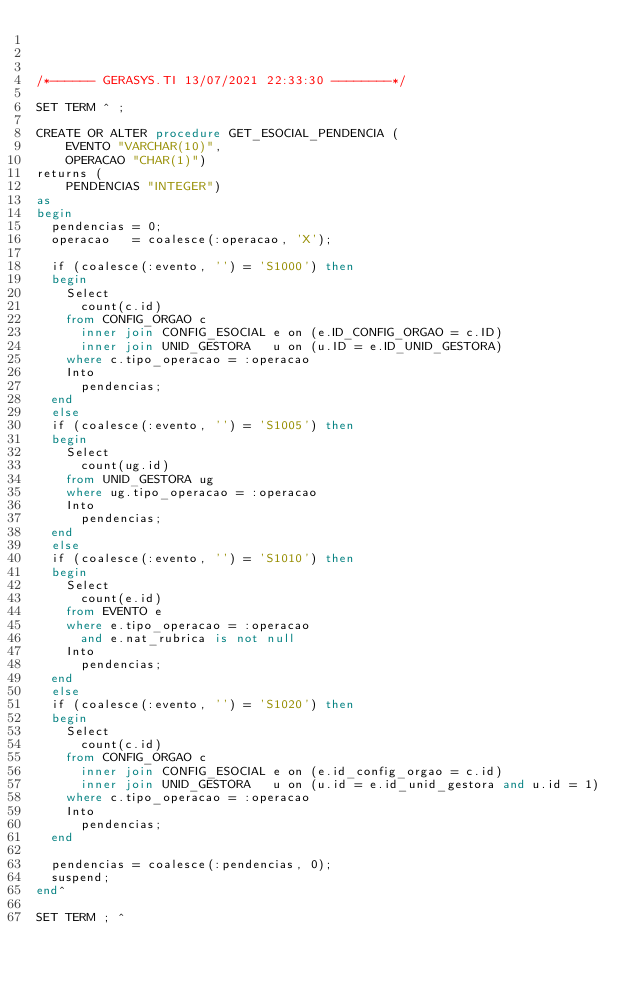<code> <loc_0><loc_0><loc_500><loc_500><_SQL_>


/*------ GERASYS.TI 13/07/2021 22:33:30 --------*/

SET TERM ^ ;

CREATE OR ALTER procedure GET_ESOCIAL_PENDENCIA (
    EVENTO "VARCHAR(10)",
    OPERACAO "CHAR(1)")
returns (
    PENDENCIAS "INTEGER")
as
begin
  pendencias = 0;
  operacao   = coalesce(:operacao, 'X');

  if (coalesce(:evento, '') = 'S1000') then
  begin
    Select
      count(c.id)
    from CONFIG_ORGAO c
      inner join CONFIG_ESOCIAL e on (e.ID_CONFIG_ORGAO = c.ID)
      inner join UNID_GESTORA   u on (u.ID = e.ID_UNID_GESTORA)
    where c.tipo_operacao = :operacao
    Into
      pendencias;
  end
  else
  if (coalesce(:evento, '') = 'S1005') then
  begin
    Select
      count(ug.id)
    from UNID_GESTORA ug
    where ug.tipo_operacao = :operacao
    Into
      pendencias;
  end
  else
  if (coalesce(:evento, '') = 'S1010') then
  begin
    Select
      count(e.id)
    from EVENTO e
    where e.tipo_operacao = :operacao
      and e.nat_rubrica is not null
    Into
      pendencias;
  end
  else
  if (coalesce(:evento, '') = 'S1020') then
  begin
    Select
      count(c.id)
    from CONFIG_ORGAO c
      inner join CONFIG_ESOCIAL e on (e.id_config_orgao = c.id)
      inner join UNID_GESTORA   u on (u.id = e.id_unid_gestora and u.id = 1)
    where c.tipo_operacao = :operacao
    Into
      pendencias;
  end

  pendencias = coalesce(:pendencias, 0);
  suspend;
end^

SET TERM ; ^

</code> 